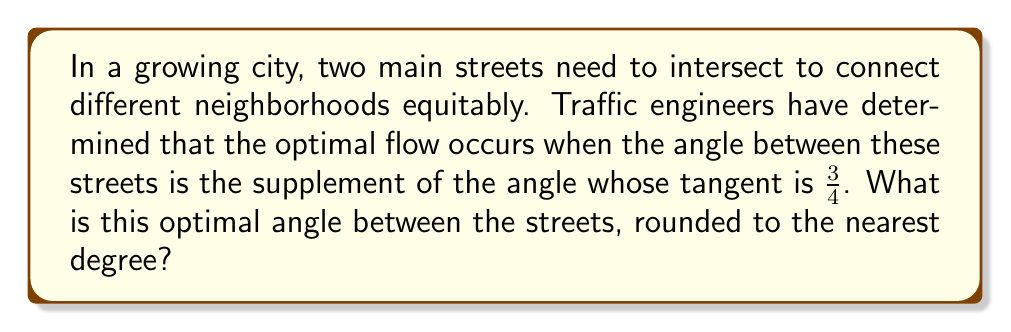Can you answer this question? Let's approach this step-by-step:

1) First, we need to find the angle whose tangent is $\frac{3}{4}$. Let's call this angle $\theta$.

   $\tan \theta = \frac{3}{4}$

2) To find $\theta$, we use the inverse tangent (arctangent) function:

   $\theta = \arctan(\frac{3}{4})$

3) Using a calculator or computer, we can determine that:

   $\theta \approx 36.87°$

4) The question asks for the supplement of this angle. The supplement of an angle is the difference between 180° and the angle.

5) Let's call our optimal angle $\alpha$. Then:

   $\alpha = 180° - \theta$

6) Substituting our value for $\theta$:

   $\alpha = 180° - 36.87° = 143.13°$

7) Rounding to the nearest degree:

   $\alpha \approx 143°$

This angle ensures optimal traffic flow while connecting different neighborhoods equitably.
Answer: 143° 